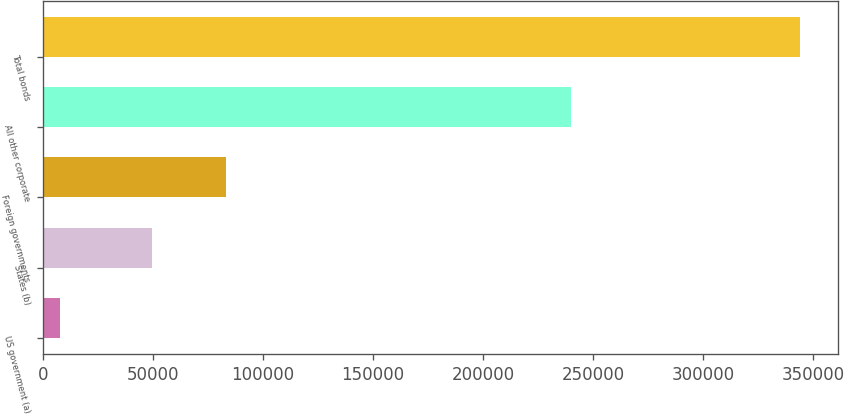Convert chart to OTSL. <chart><loc_0><loc_0><loc_500><loc_500><bar_chart><fcel>US government (a)<fcel>States (b)<fcel>Foreign governments<fcel>All other corporate<fcel>Total bonds<nl><fcel>7878<fcel>49654<fcel>83306.1<fcel>240259<fcel>344399<nl></chart> 